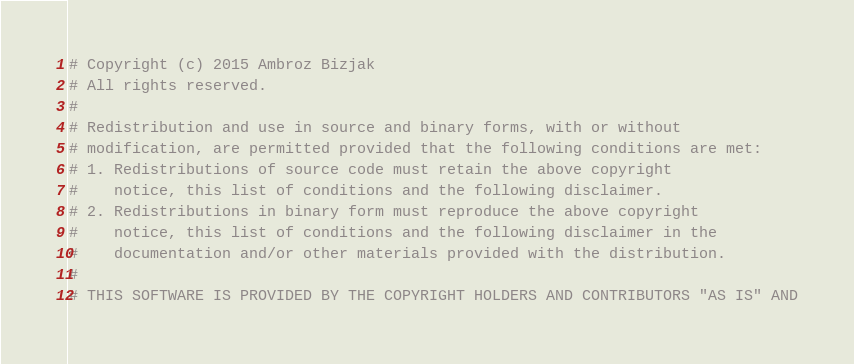<code> <loc_0><loc_0><loc_500><loc_500><_Python_># Copyright (c) 2015 Ambroz Bizjak
# All rights reserved.
# 
# Redistribution and use in source and binary forms, with or without
# modification, are permitted provided that the following conditions are met:
# 1. Redistributions of source code must retain the above copyright
#    notice, this list of conditions and the following disclaimer.
# 2. Redistributions in binary form must reproduce the above copyright
#    notice, this list of conditions and the following disclaimer in the
#    documentation and/or other materials provided with the distribution.
# 
# THIS SOFTWARE IS PROVIDED BY THE COPYRIGHT HOLDERS AND CONTRIBUTORS "AS IS" AND</code> 